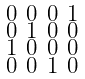<formula> <loc_0><loc_0><loc_500><loc_500>\begin{smallmatrix} 0 & 0 & 0 & 1 \\ 0 & 1 & 0 & 0 \\ 1 & 0 & 0 & 0 \\ 0 & 0 & 1 & 0 \end{smallmatrix}</formula> 